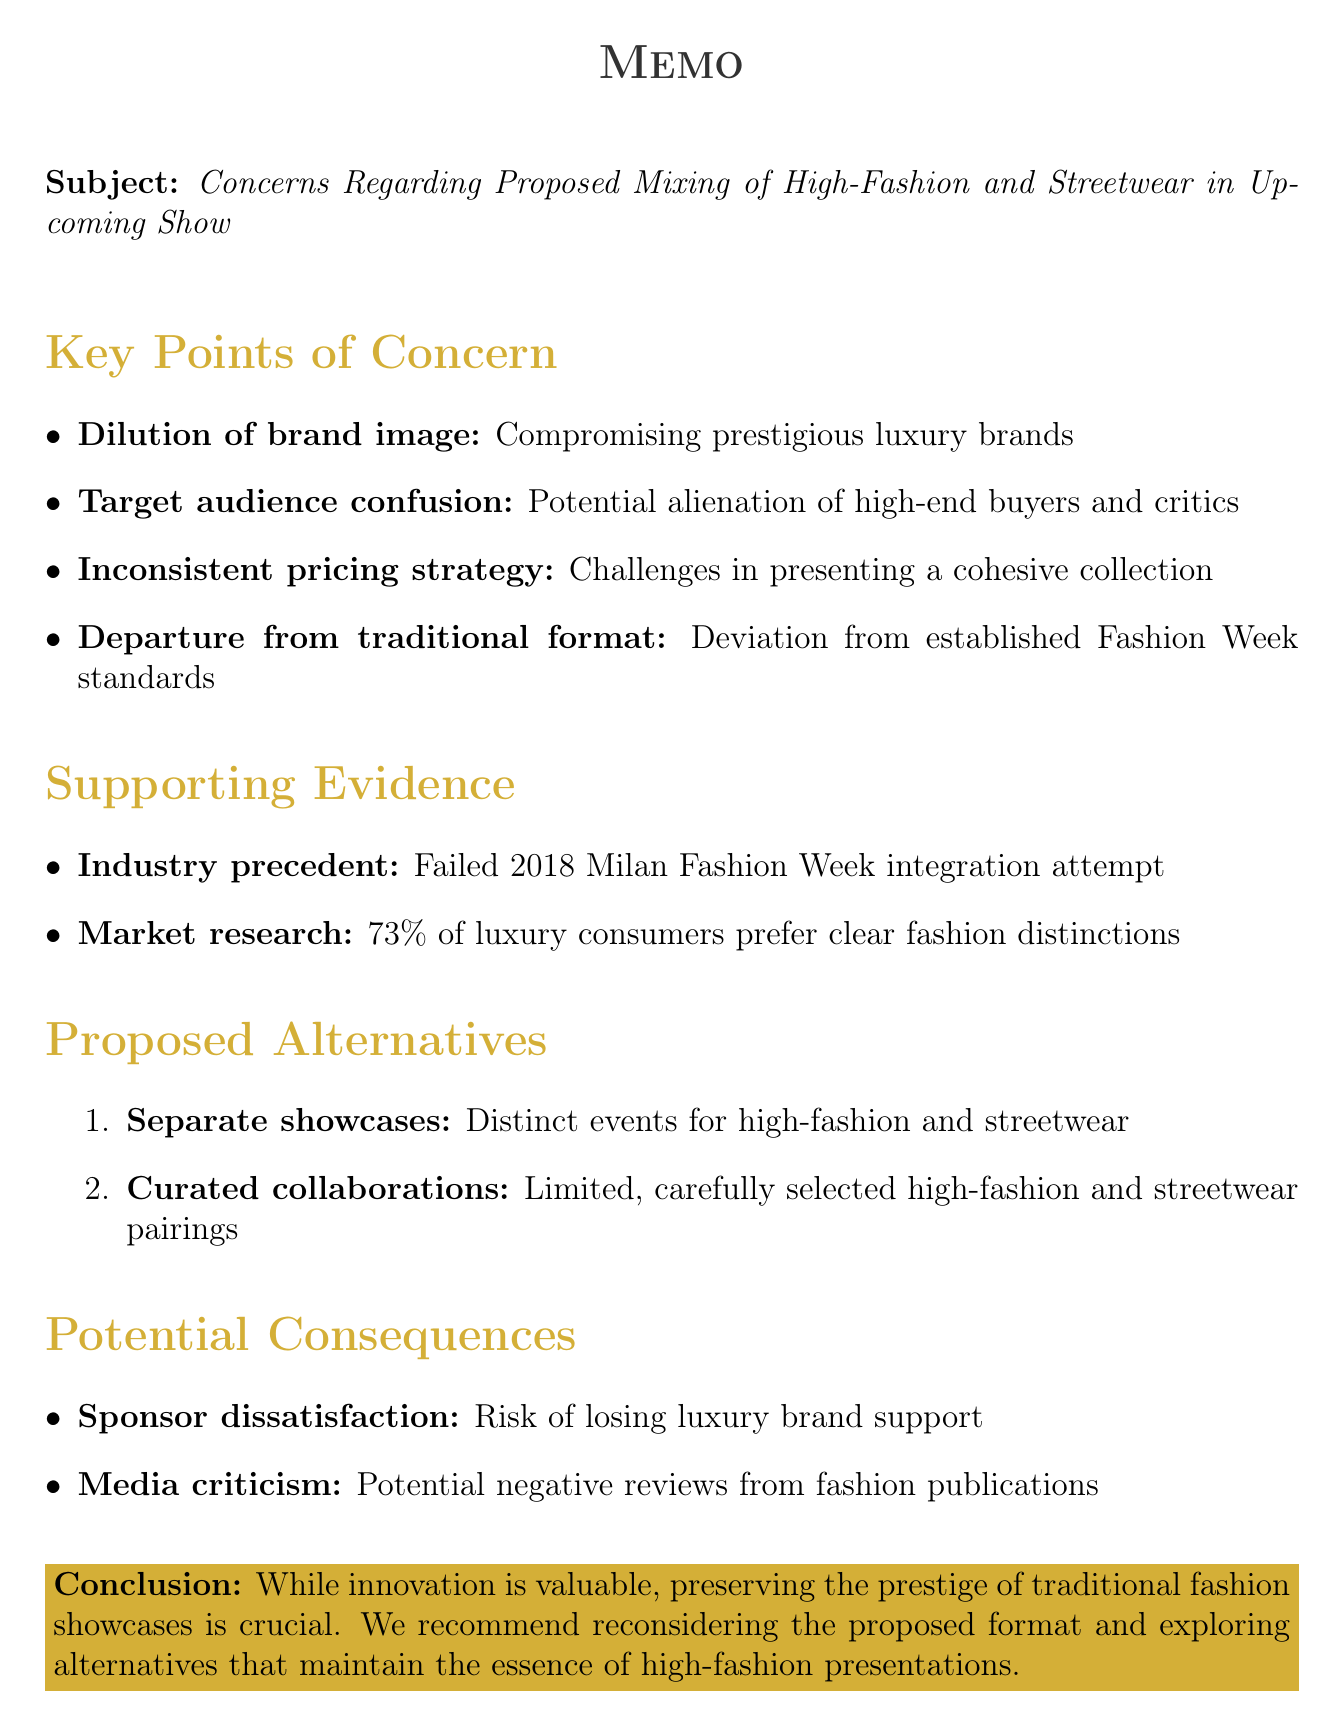What is the main subject of the memo? The main subject is about the proposed mixing of high-fashion and streetwear in the upcoming show.
Answer: Concerns Regarding Proposed Mixing of High-Fashion and Streetwear in Upcoming Show How many key points of concern are listed? There are four key points of concern mentioned in the memo.
Answer: 4 What percentage of luxury fashion consumers prefer a clear distinction between high-fashion and streetwear? This percentage is derived from the referenced market research provided in the memo.
Answer: 73% What is one proposed alternative to mixing collections? The memo lists alternatives to keep the collections distinct or carefully curated.
Answer: Separate showcases Which industry event is referenced as a precedent for failure? An event that serves as an example for failure regarding the proposed idea is mentioned.
Answer: 2018 Milan Fashion Week What potential consequence involves luxury sponsors? This consequence refers to the risk of losing support from major luxury brands if the proposal is implemented.
Answer: Sponsor dissatisfaction What is emphasized as crucial in the conclusion of the memo? The conclusion summarizes the importance of maintaining a certain standards within high-fashion shows.
Answer: Prestige and traditions of high-fashion shows How does the memo classify the proposed mixing of collections? The memo refers to this idea as a significant deviation from established practices.
Answer: Departure from traditional format 